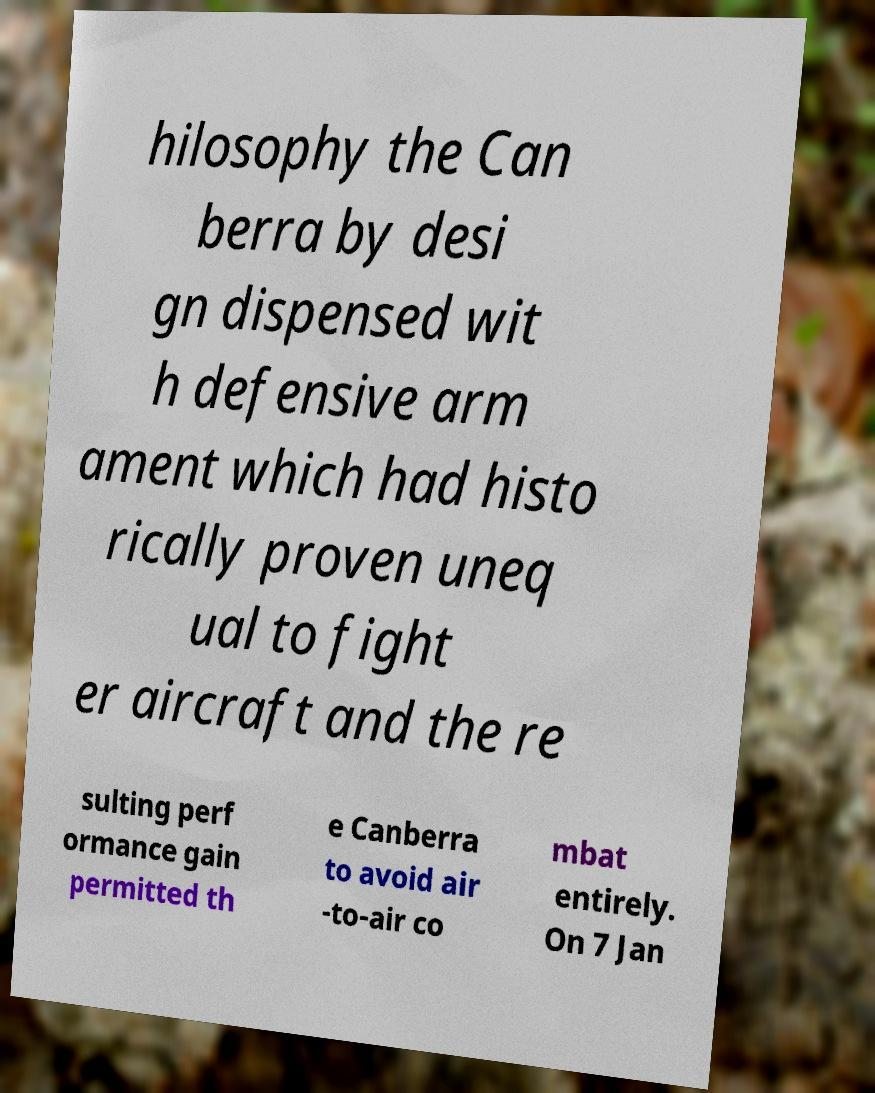There's text embedded in this image that I need extracted. Can you transcribe it verbatim? hilosophy the Can berra by desi gn dispensed wit h defensive arm ament which had histo rically proven uneq ual to fight er aircraft and the re sulting perf ormance gain permitted th e Canberra to avoid air -to-air co mbat entirely. On 7 Jan 